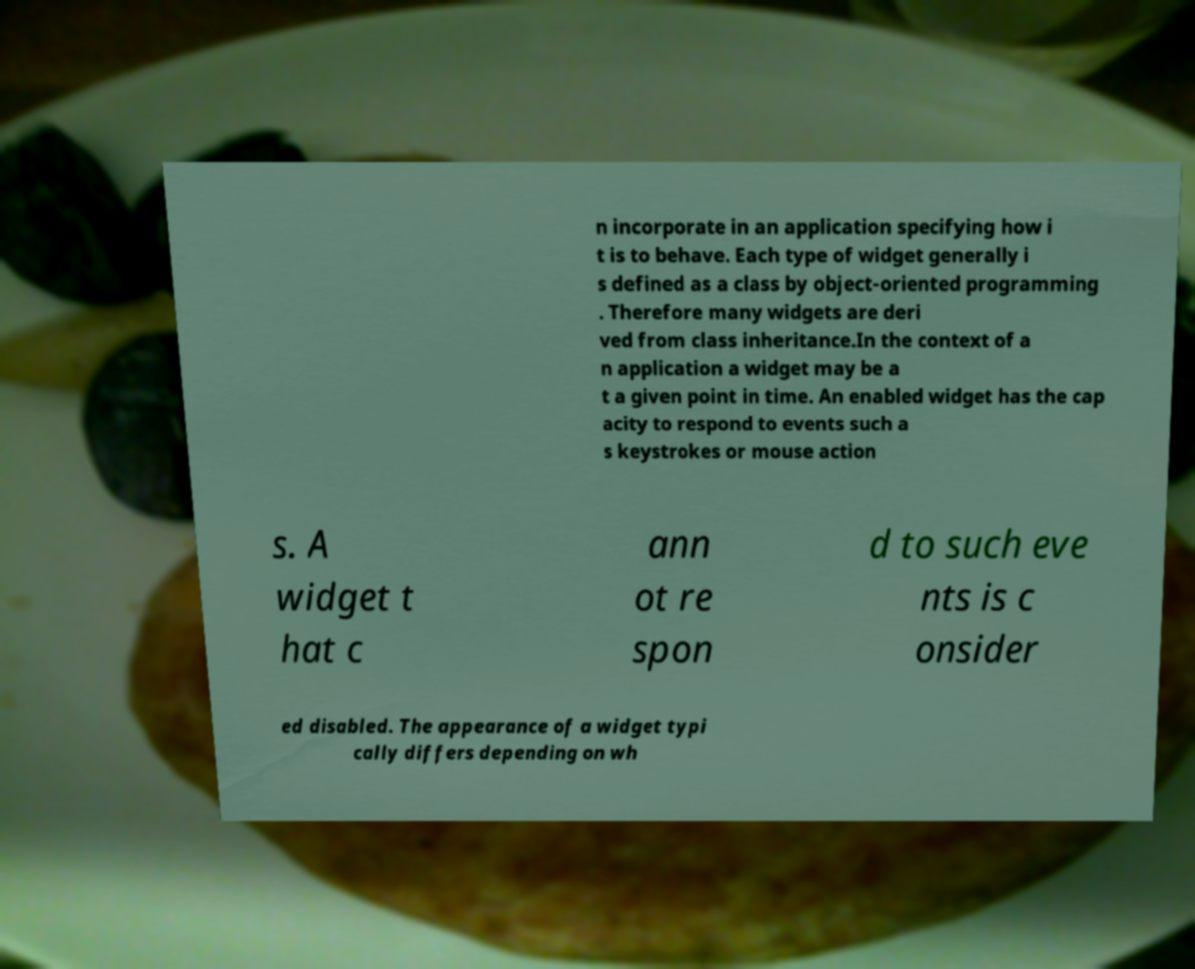Could you assist in decoding the text presented in this image and type it out clearly? n incorporate in an application specifying how i t is to behave. Each type of widget generally i s defined as a class by object-oriented programming . Therefore many widgets are deri ved from class inheritance.In the context of a n application a widget may be a t a given point in time. An enabled widget has the cap acity to respond to events such a s keystrokes or mouse action s. A widget t hat c ann ot re spon d to such eve nts is c onsider ed disabled. The appearance of a widget typi cally differs depending on wh 